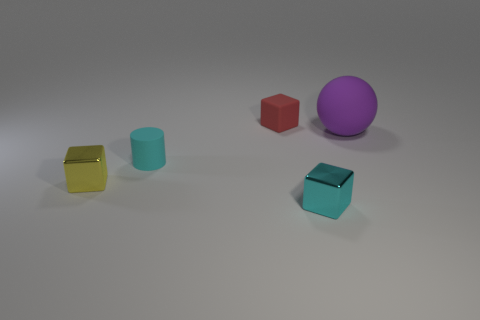There is a thing that is both behind the cyan cylinder and on the right side of the red cube; what is its size?
Offer a terse response. Large. What material is the tiny red thing that is the same shape as the yellow shiny object?
Provide a succinct answer. Rubber. There is a block that is made of the same material as the small yellow object; what is its size?
Give a very brief answer. Small. How many red rubber objects have the same shape as the yellow thing?
Provide a short and direct response. 1. What number of big brown balls are there?
Provide a succinct answer. 0. There is a metallic thing behind the small cyan metallic cube; does it have the same shape as the tiny red matte thing?
Your answer should be very brief. Yes. What material is the cyan cylinder that is the same size as the matte block?
Your answer should be compact. Rubber. Are there any other cubes that have the same material as the cyan block?
Offer a very short reply. Yes. Do the small yellow object and the tiny object in front of the tiny yellow shiny cube have the same shape?
Keep it short and to the point. Yes. How many rubber objects are in front of the red matte object and behind the tiny cylinder?
Make the answer very short. 1. 